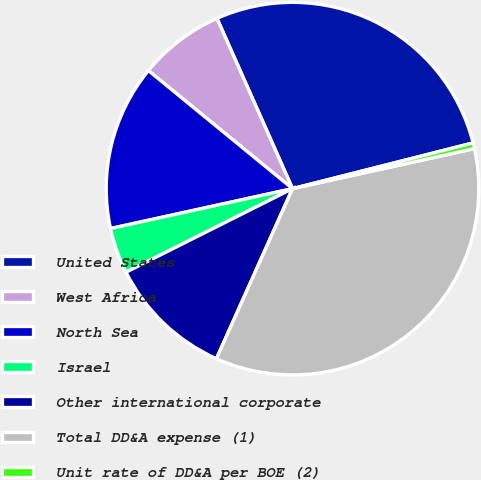<chart> <loc_0><loc_0><loc_500><loc_500><pie_chart><fcel>United States<fcel>West Africa<fcel>North Sea<fcel>Israel<fcel>Other international corporate<fcel>Total DD&A expense (1)<fcel>Unit rate of DD&A per BOE (2)<nl><fcel>27.7%<fcel>7.43%<fcel>14.36%<fcel>3.97%<fcel>10.9%<fcel>35.15%<fcel>0.5%<nl></chart> 